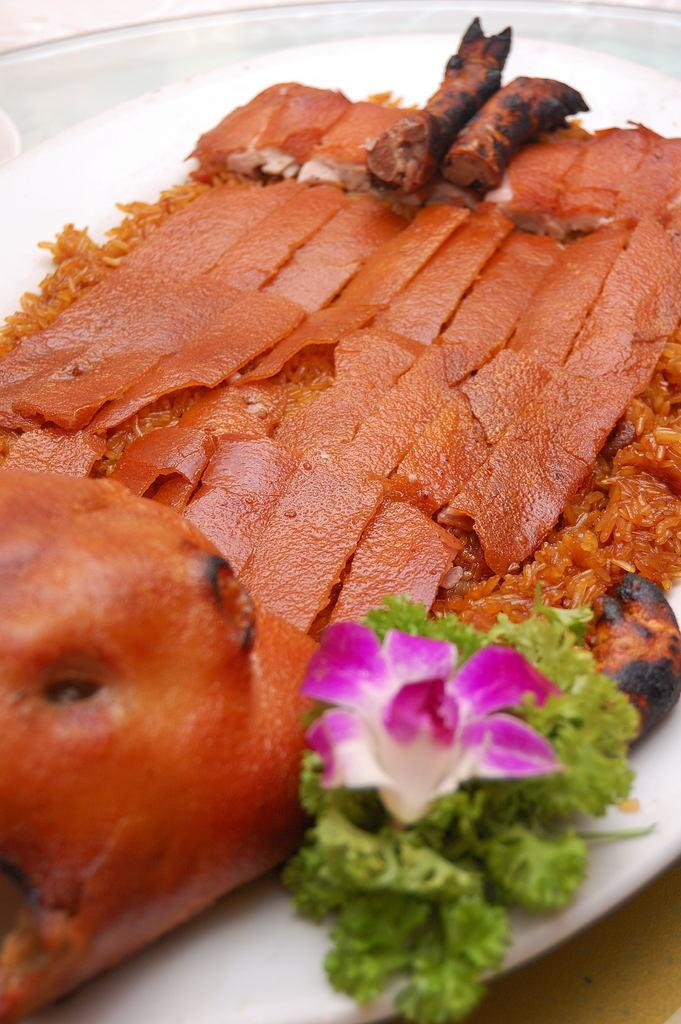What is on the plate in the image? There are food items on a plate, and there is also a flower on the plate. Where is the plate located? The plate is placed on a table. What type of tomatoes can be seen on the tongue of the person in the image? There is no person or tomatoes present in the image; it only features a plate with food items and a flower. 